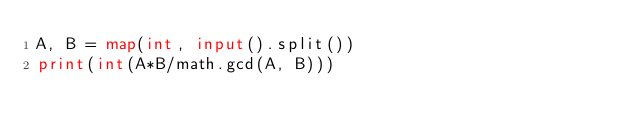<code> <loc_0><loc_0><loc_500><loc_500><_Python_>A, B = map(int, input().split())
print(int(A*B/math.gcd(A, B)))</code> 